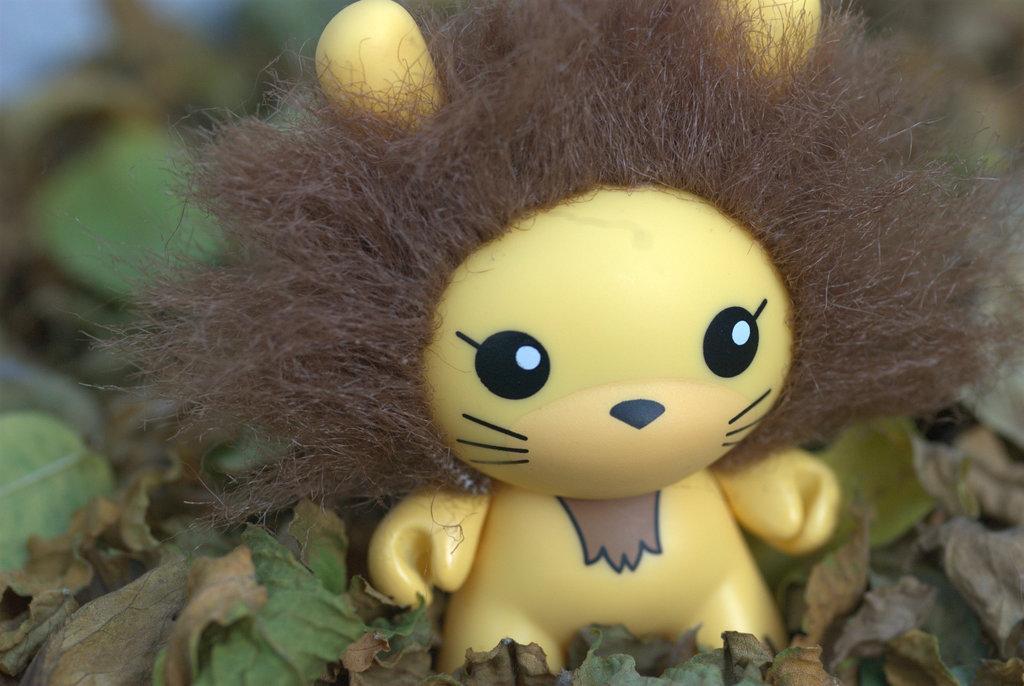Could you give a brief overview of what you see in this image? In this picture we can see a toy and few leaves. 